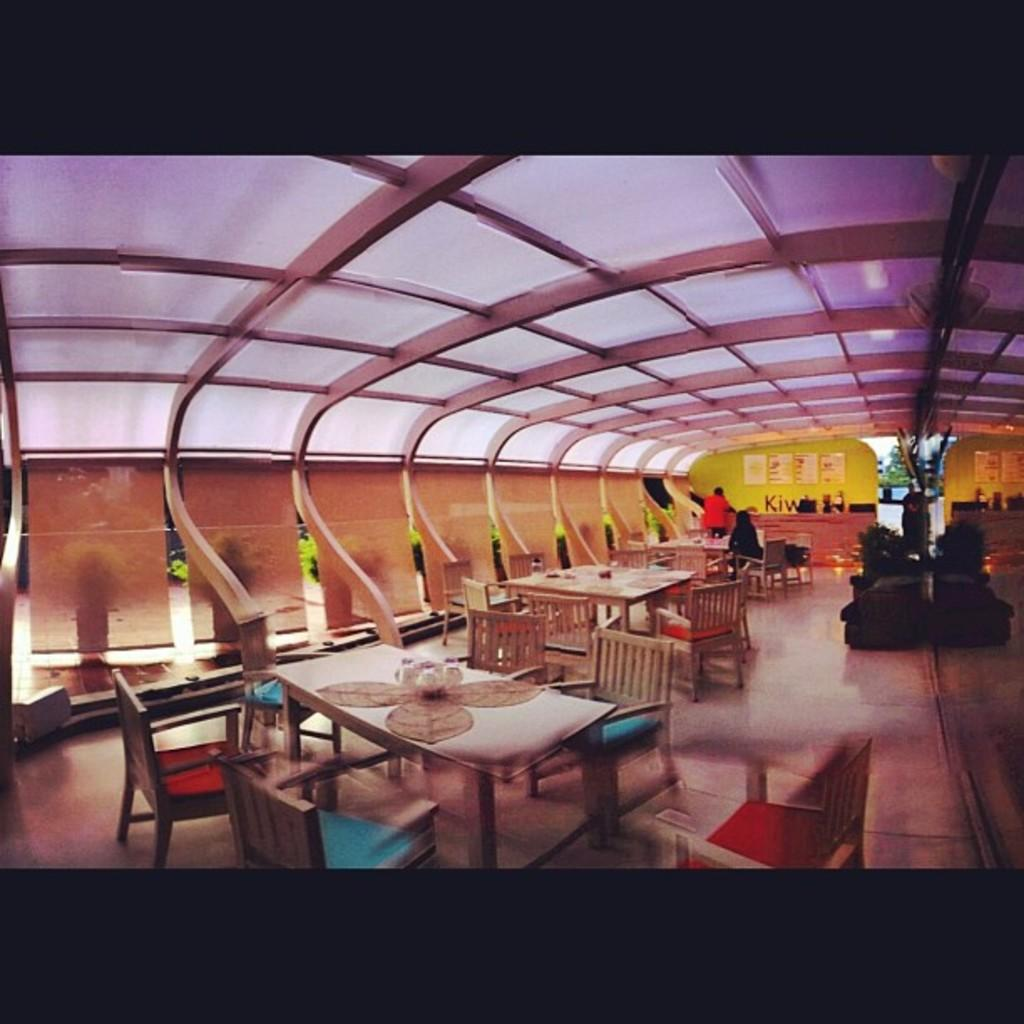What type of furniture is present in the image? There are tables and chairs in the image. What else can be seen in the image besides furniture? There are people in the image. What is on the wall in the background? There are boards placed on the wall in the background. What is visible at the top of the image? There is a roof visible at the top of the image. What songs are being sung by the people in the image? There is no information about songs being sung in the image. Can you see a skateboard being used by anyone in the image? There is no skateboard present in the image. 